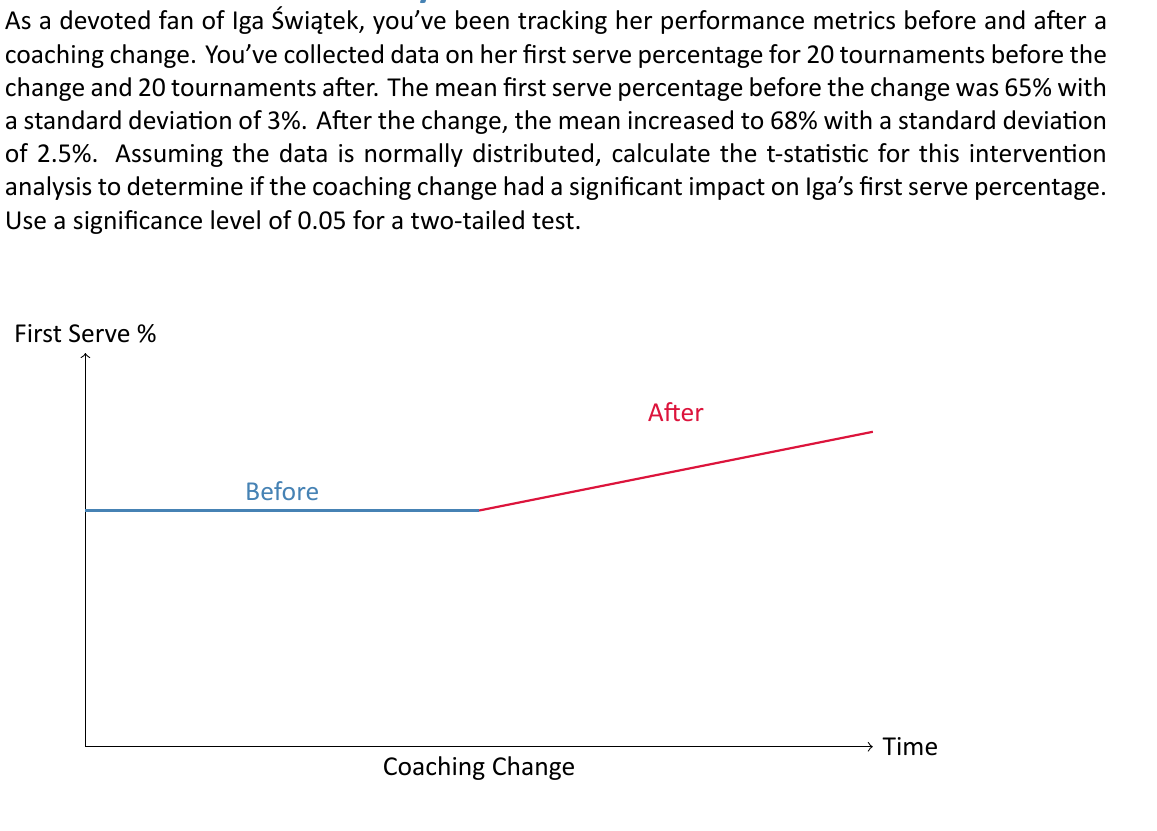Solve this math problem. To assess the impact of the coaching change on Iga Świątek's first serve percentage, we'll use the independent samples t-test. The steps are as follows:

1) First, we need to calculate the pooled standard error. The formula is:

   $$SE_p = \sqrt{\frac{s_1^2}{n_1} + \frac{s_2^2}{n_2}}$$

   Where $s_1$ and $s_2$ are the standard deviations, and $n_1$ and $n_2$ are the sample sizes.

2) Plugging in our values:
   $$SE_p = \sqrt{\frac{3^2}{20} + \frac{2.5^2}{20}} = \sqrt{0.45 + 0.3125} = \sqrt{0.7625} = 0.8732$$

3) Now we can calculate the t-statistic using the formula:

   $$t = \frac{\bar{x}_2 - \bar{x}_1}{SE_p}$$

   Where $\bar{x}_2$ and $\bar{x}_1$ are the means after and before the change respectively.

4) Plugging in our values:
   $$t = \frac{68 - 65}{0.8732} = \frac{3}{0.8732} = 3.4356$$

5) For a two-tailed test with a significance level of 0.05 and 38 degrees of freedom (n1 + n2 - 2 = 20 + 20 - 2 = 38), the critical t-value is approximately ±2.024.

6) Since our calculated t-value (3.4356) is greater than the critical value (2.024), we can conclude that the difference is statistically significant.
Answer: 3.4356 